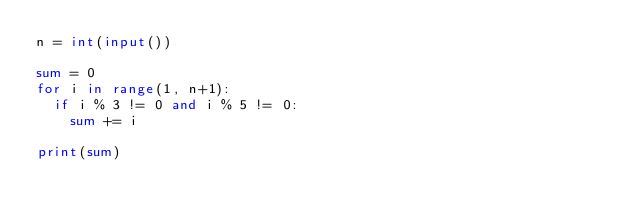Convert code to text. <code><loc_0><loc_0><loc_500><loc_500><_Python_>n = int(input())

sum = 0
for i in range(1, n+1):
  if i % 3 != 0 and i % 5 != 0:
    sum += i

print(sum)</code> 